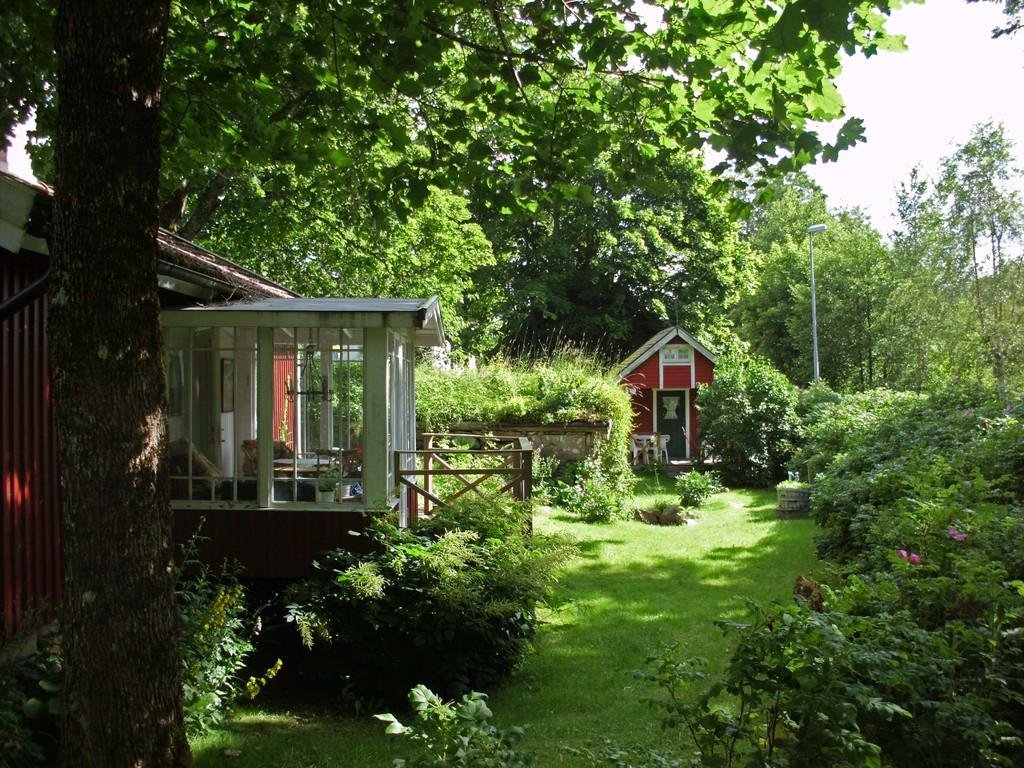What type of structures can be seen in the image? There are houses in the image. What type of vegetation is present in the image? There are trees and plants in the image. What covers the ground in the image? There is grass on the ground in the image. What is the condition of the sky in the image? The sky is cloudy in the image. What type of flower is growing in the image? There is no flower present in the image; it features houses, trees, plants, grass, and a cloudy sky. 